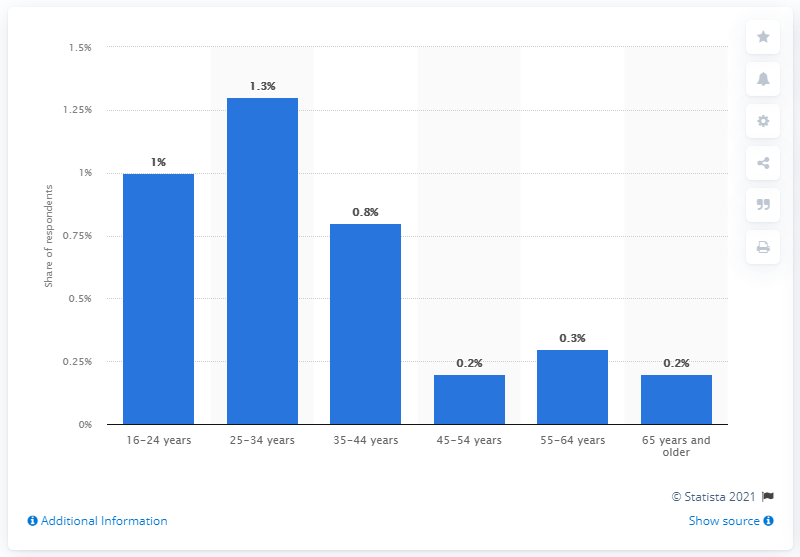Specify some key components in this picture. According to the study, only 0.2% of individuals aged 65 and older reported being problem gamblers. 